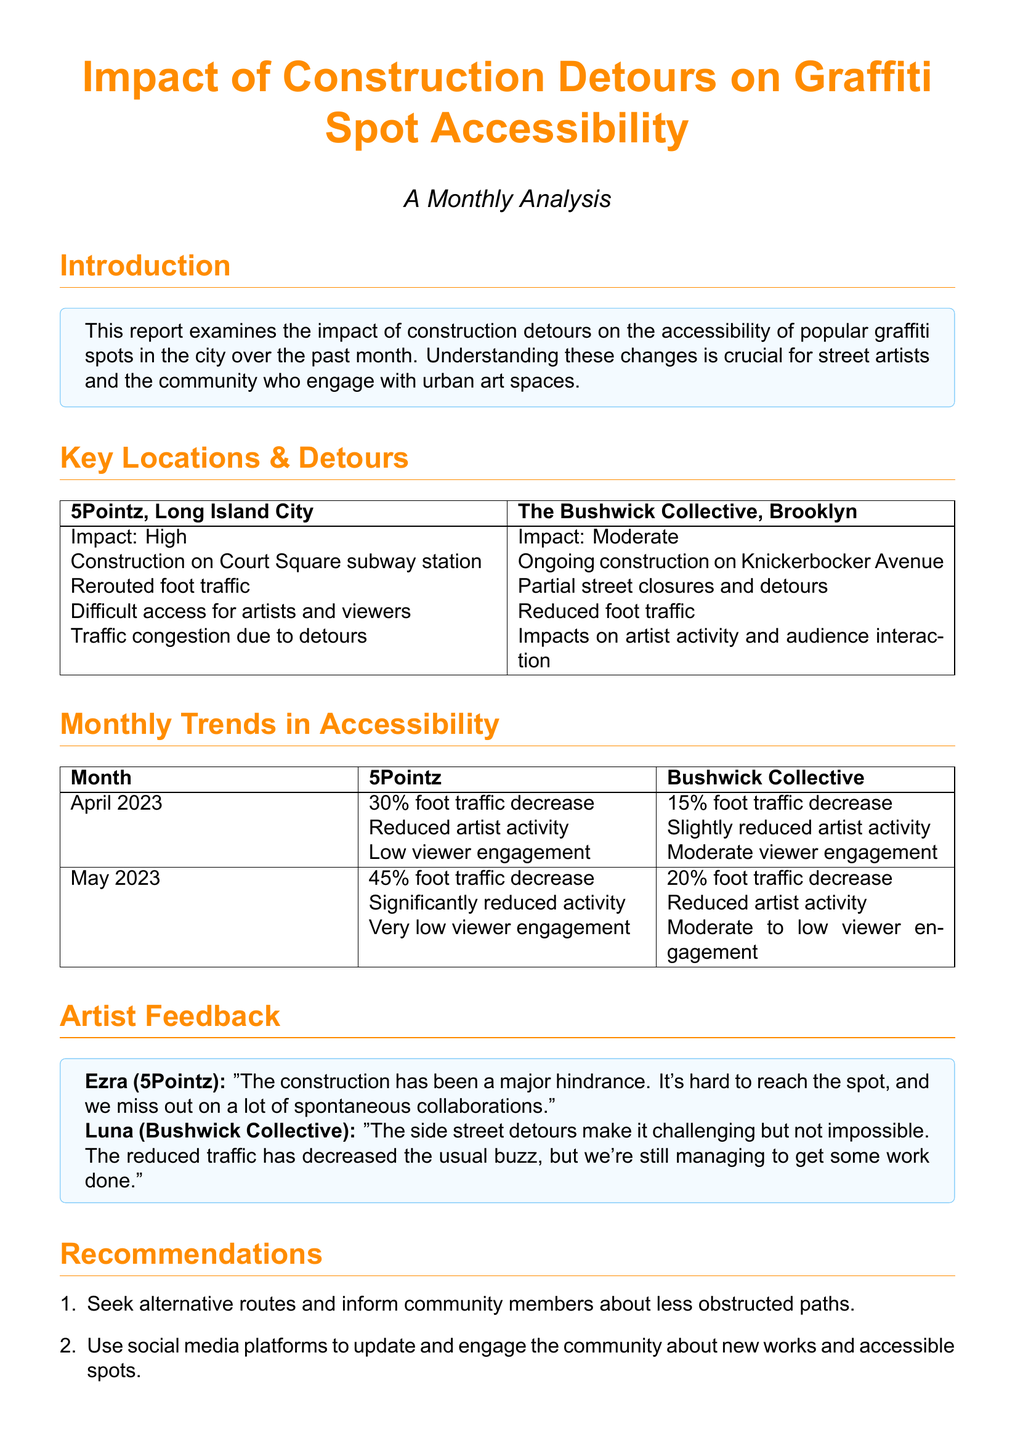What is the main focus of the report? The report examines the impact of construction detours on graffiti spot accessibility in the city over the past month.
Answer: Accessibility Which graffiti spot has a high impact due to construction? The document states that 5Pointz has a high impact due to construction at Court Square subway station.
Answer: 5Pointz What was the foot traffic decrease at Bushwick Collective in April 2023? The report indicates a 15% foot traffic decrease at Bushwick Collective in April 2023.
Answer: 15% Who is quoted regarding the impact of construction at 5Pointz? Ezra is quoted in the section about artist feedback concerning the impact of construction at 5Pointz.
Answer: Ezra What is one recommendation provided in the report? The report suggests seeking alternative routes and informing community members about less obstructed paths.
Answer: Seek alternative routes What was the foot traffic decrease at 5Pointz in May 2023? The document shows a 45% foot traffic decrease at 5Pointz in May 2023.
Answer: 45% Which area experiences reduced foot traffic due to ongoing construction on Knickerbocker Avenue? The Bushwick Collective experiences reduced foot traffic due to ongoing construction on Knickerbocker Avenue.
Answer: Bushwick Collective What was the engagement level of viewers at 5Pointz in May 2023? At 5Pointz, the engagement level of viewers in May 2023 was described as very low.
Answer: Very low What are artists missing out on due to construction at 5Pointz? Ezra mentions missing out on a lot of spontaneous collaborations due to the construction hindrance.
Answer: Spontaneous collaborations 